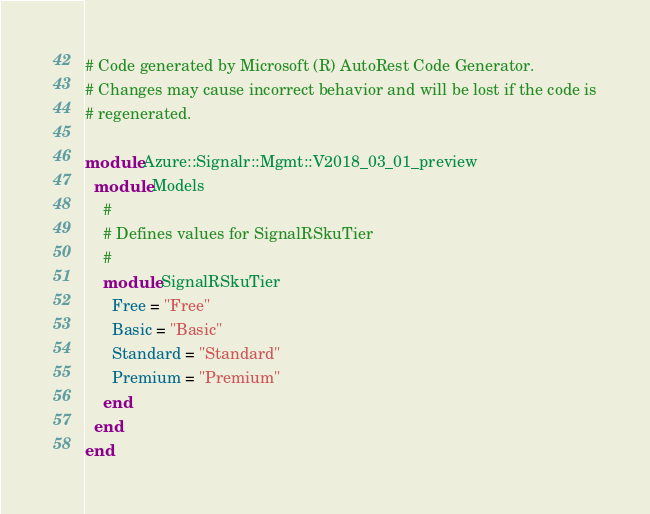Convert code to text. <code><loc_0><loc_0><loc_500><loc_500><_Ruby_># Code generated by Microsoft (R) AutoRest Code Generator.
# Changes may cause incorrect behavior and will be lost if the code is
# regenerated.

module Azure::Signalr::Mgmt::V2018_03_01_preview
  module Models
    #
    # Defines values for SignalRSkuTier
    #
    module SignalRSkuTier
      Free = "Free"
      Basic = "Basic"
      Standard = "Standard"
      Premium = "Premium"
    end
  end
end
</code> 